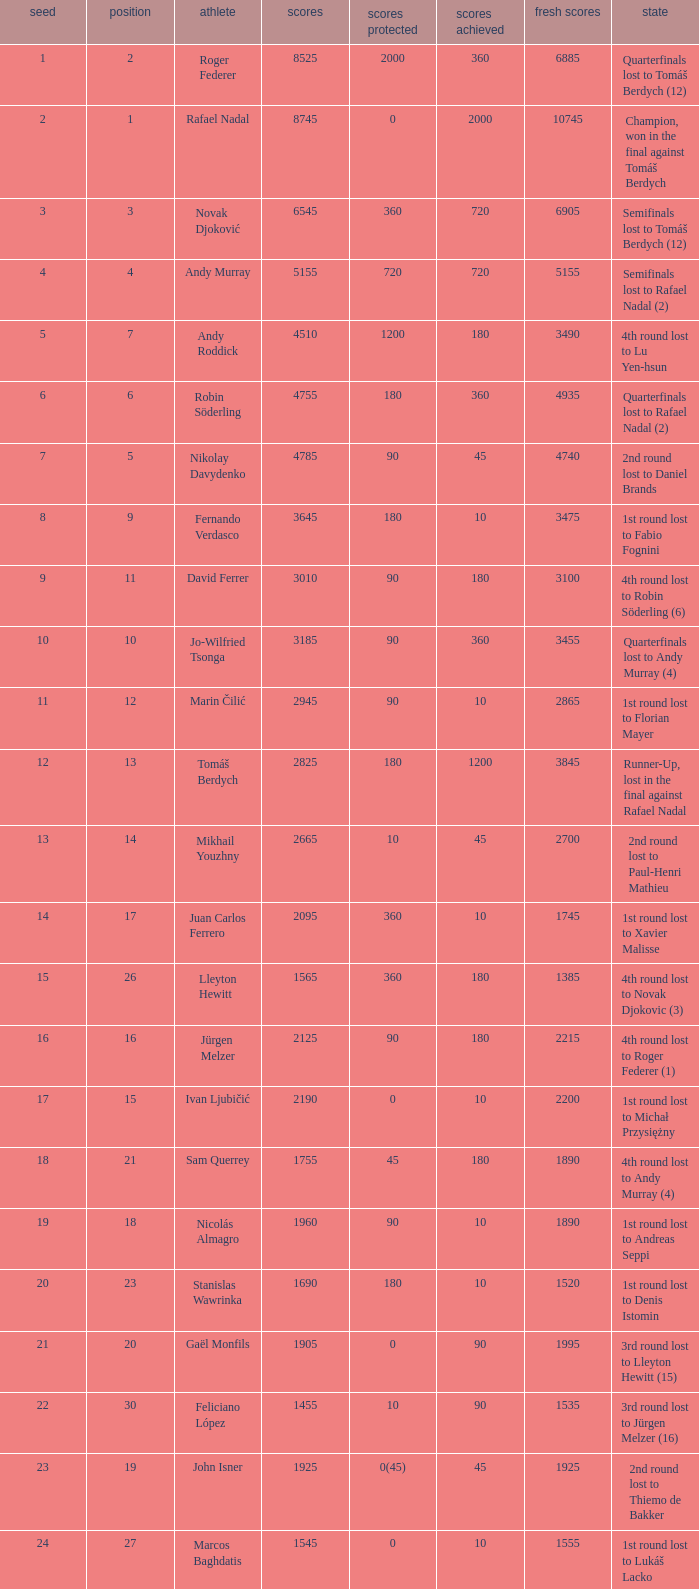Name the status for points 3185 Quarterfinals lost to Andy Murray (4). 